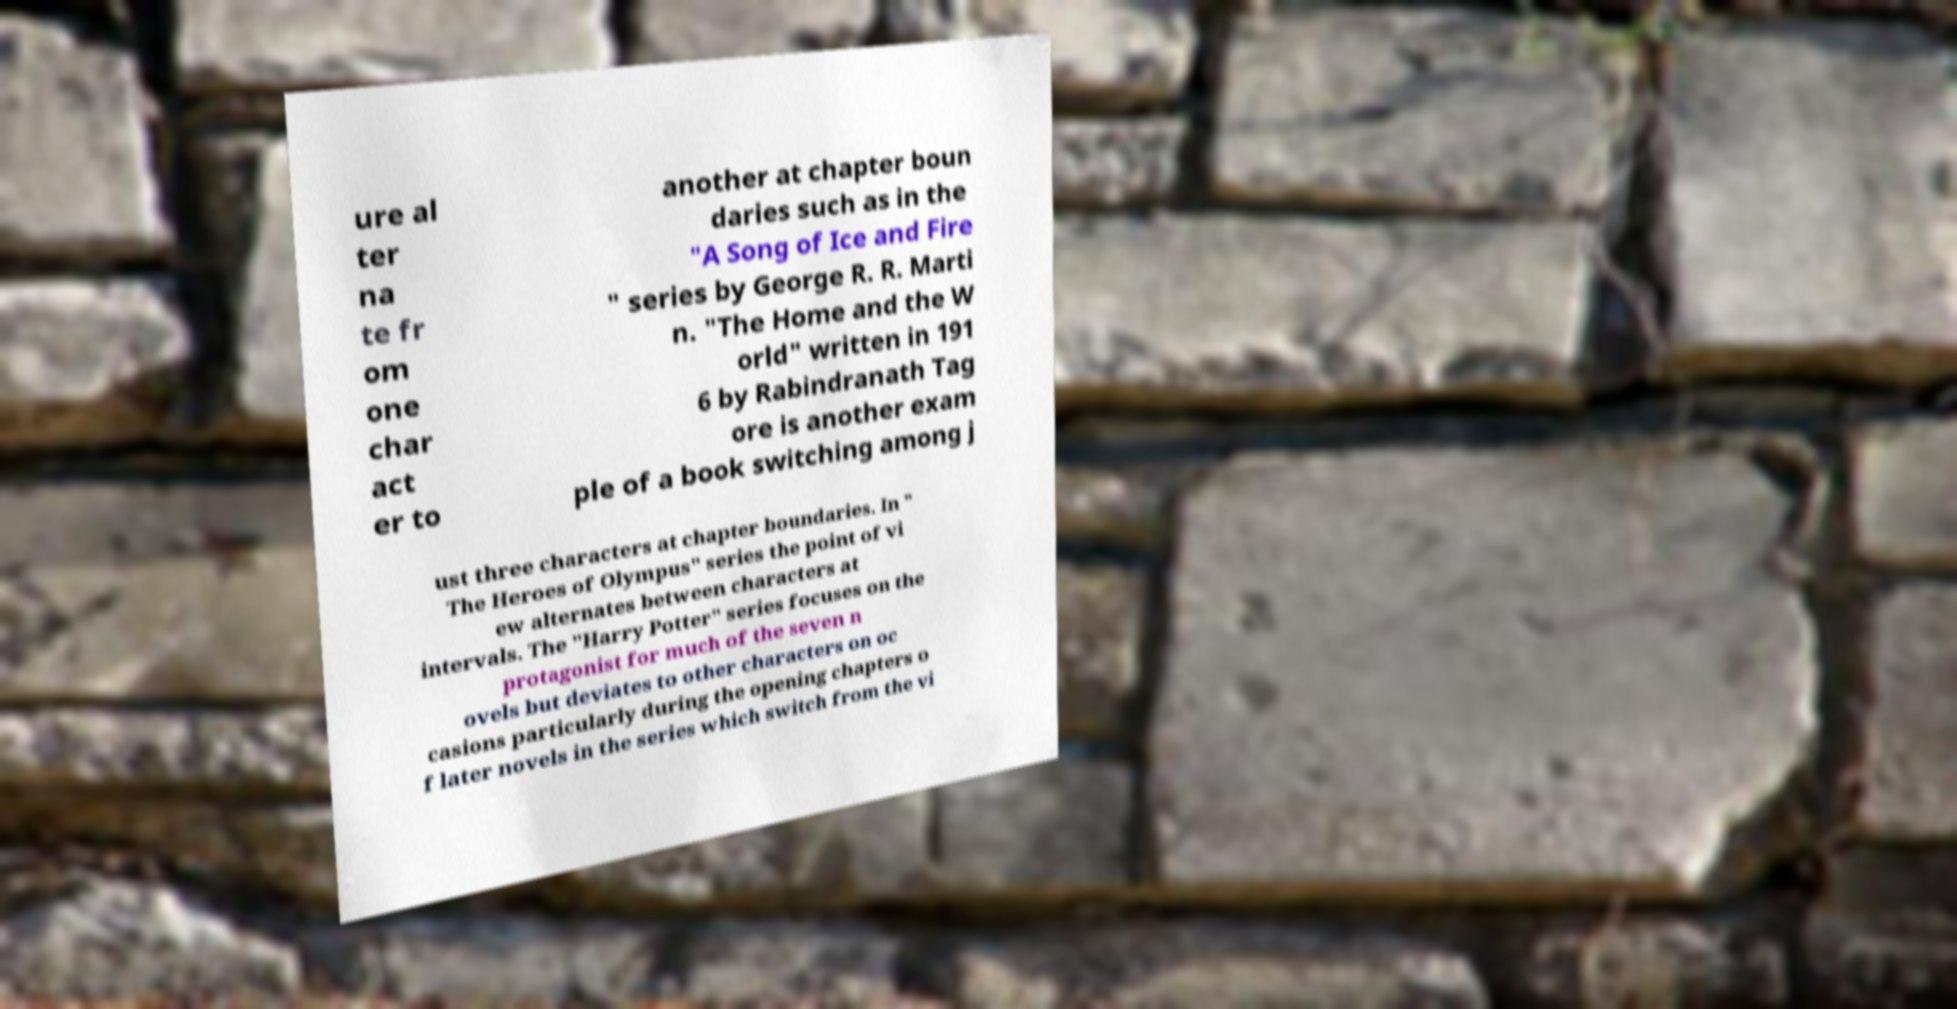What messages or text are displayed in this image? I need them in a readable, typed format. ure al ter na te fr om one char act er to another at chapter boun daries such as in the "A Song of Ice and Fire " series by George R. R. Marti n. "The Home and the W orld" written in 191 6 by Rabindranath Tag ore is another exam ple of a book switching among j ust three characters at chapter boundaries. In " The Heroes of Olympus" series the point of vi ew alternates between characters at intervals. The "Harry Potter" series focuses on the protagonist for much of the seven n ovels but deviates to other characters on oc casions particularly during the opening chapters o f later novels in the series which switch from the vi 